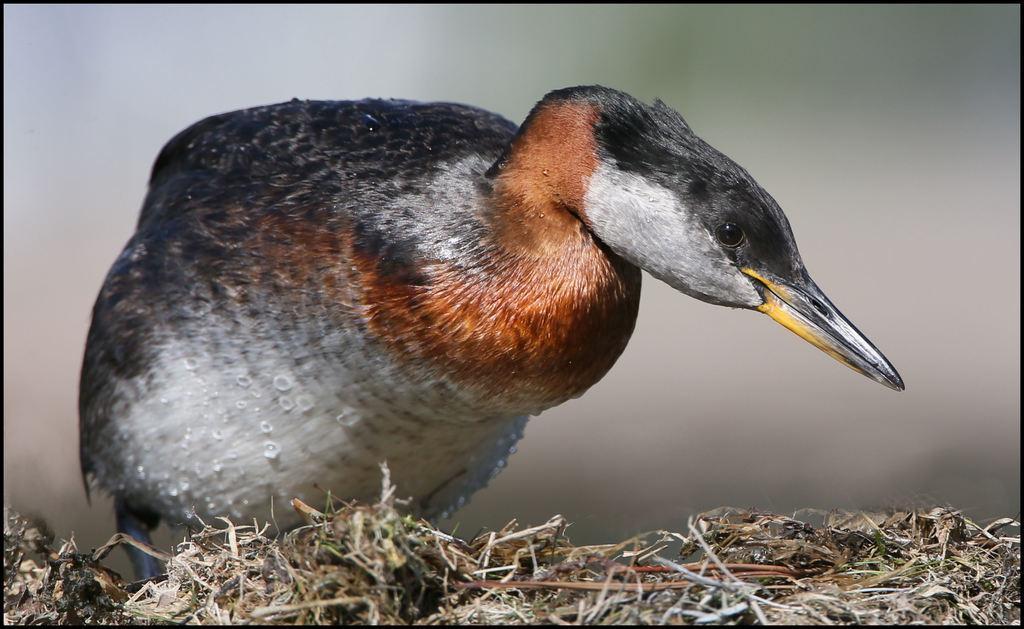How would you summarize this image in a sentence or two? In this image there is a bird standing on the dried grass, and there is blur background. 